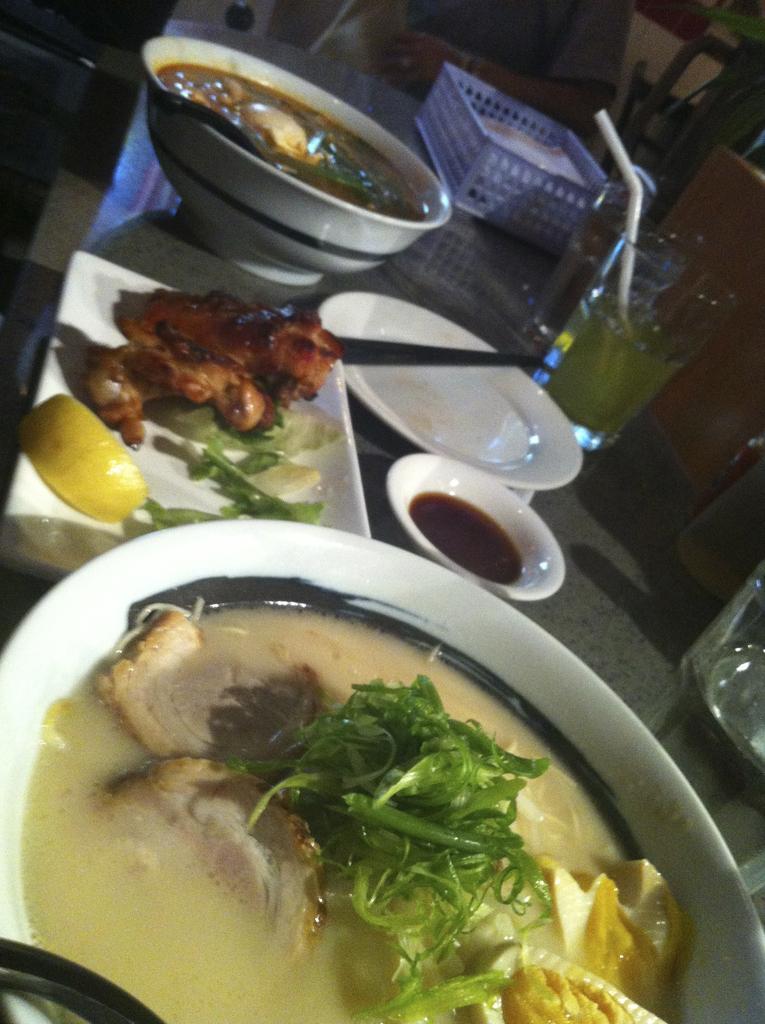Please provide a concise description of this image. In the image there is meat soup with leaves and beside it there are fried meat pieces along with some bowls with food,glass and a basket on the table. 